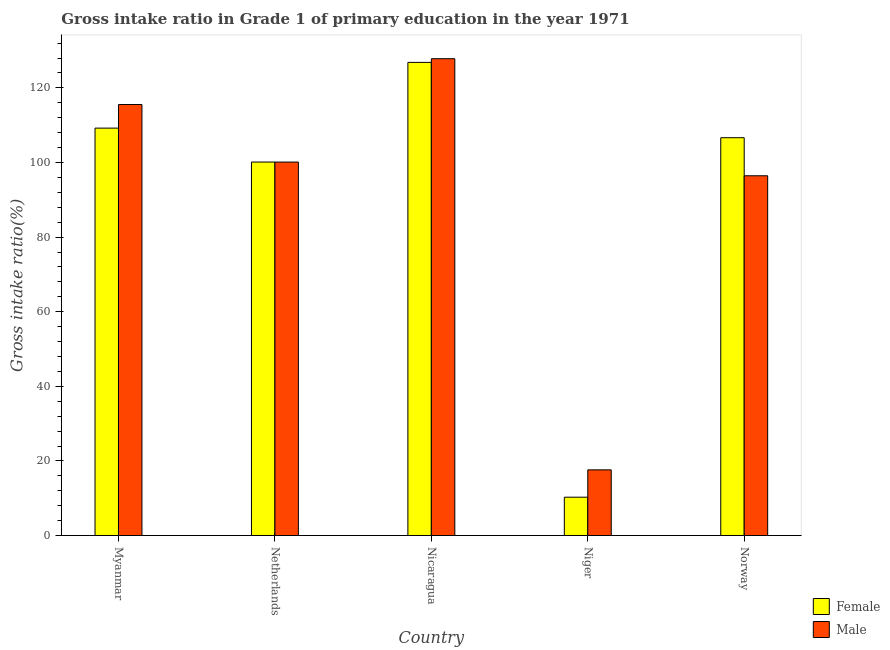How many different coloured bars are there?
Offer a very short reply. 2. Are the number of bars per tick equal to the number of legend labels?
Provide a short and direct response. Yes. How many bars are there on the 3rd tick from the left?
Make the answer very short. 2. What is the label of the 2nd group of bars from the left?
Provide a succinct answer. Netherlands. What is the gross intake ratio(female) in Niger?
Your answer should be compact. 10.28. Across all countries, what is the maximum gross intake ratio(male)?
Provide a short and direct response. 127.83. Across all countries, what is the minimum gross intake ratio(female)?
Make the answer very short. 10.28. In which country was the gross intake ratio(male) maximum?
Offer a terse response. Nicaragua. In which country was the gross intake ratio(male) minimum?
Offer a very short reply. Niger. What is the total gross intake ratio(male) in the graph?
Keep it short and to the point. 457.56. What is the difference between the gross intake ratio(female) in Myanmar and that in Nicaragua?
Provide a short and direct response. -17.62. What is the difference between the gross intake ratio(female) in Niger and the gross intake ratio(male) in Myanmar?
Your answer should be very brief. -105.26. What is the average gross intake ratio(female) per country?
Your answer should be compact. 90.63. What is the difference between the gross intake ratio(male) and gross intake ratio(female) in Niger?
Provide a short and direct response. 7.33. What is the ratio of the gross intake ratio(female) in Nicaragua to that in Norway?
Keep it short and to the point. 1.19. Is the difference between the gross intake ratio(male) in Myanmar and Nicaragua greater than the difference between the gross intake ratio(female) in Myanmar and Nicaragua?
Your answer should be compact. Yes. What is the difference between the highest and the second highest gross intake ratio(male)?
Ensure brevity in your answer.  12.28. What is the difference between the highest and the lowest gross intake ratio(female)?
Ensure brevity in your answer.  116.56. In how many countries, is the gross intake ratio(male) greater than the average gross intake ratio(male) taken over all countries?
Ensure brevity in your answer.  4. Is the sum of the gross intake ratio(male) in Myanmar and Netherlands greater than the maximum gross intake ratio(female) across all countries?
Ensure brevity in your answer.  Yes. What does the 2nd bar from the left in Myanmar represents?
Your answer should be very brief. Male. Are all the bars in the graph horizontal?
Ensure brevity in your answer.  No. How many countries are there in the graph?
Ensure brevity in your answer.  5. What is the difference between two consecutive major ticks on the Y-axis?
Provide a succinct answer. 20. Are the values on the major ticks of Y-axis written in scientific E-notation?
Your answer should be very brief. No. Does the graph contain any zero values?
Give a very brief answer. No. Does the graph contain grids?
Provide a short and direct response. No. Where does the legend appear in the graph?
Your answer should be compact. Bottom right. How are the legend labels stacked?
Offer a very short reply. Vertical. What is the title of the graph?
Your answer should be compact. Gross intake ratio in Grade 1 of primary education in the year 1971. What is the label or title of the X-axis?
Keep it short and to the point. Country. What is the label or title of the Y-axis?
Provide a short and direct response. Gross intake ratio(%). What is the Gross intake ratio(%) of Female in Myanmar?
Make the answer very short. 109.22. What is the Gross intake ratio(%) in Male in Myanmar?
Give a very brief answer. 115.55. What is the Gross intake ratio(%) of Female in Netherlands?
Your answer should be very brief. 100.13. What is the Gross intake ratio(%) of Male in Netherlands?
Offer a terse response. 100.12. What is the Gross intake ratio(%) of Female in Nicaragua?
Your response must be concise. 126.84. What is the Gross intake ratio(%) in Male in Nicaragua?
Your answer should be compact. 127.83. What is the Gross intake ratio(%) in Female in Niger?
Provide a short and direct response. 10.28. What is the Gross intake ratio(%) of Male in Niger?
Offer a terse response. 17.61. What is the Gross intake ratio(%) of Female in Norway?
Your answer should be very brief. 106.65. What is the Gross intake ratio(%) in Male in Norway?
Your answer should be very brief. 96.45. Across all countries, what is the maximum Gross intake ratio(%) in Female?
Give a very brief answer. 126.84. Across all countries, what is the maximum Gross intake ratio(%) of Male?
Give a very brief answer. 127.83. Across all countries, what is the minimum Gross intake ratio(%) of Female?
Offer a very short reply. 10.28. Across all countries, what is the minimum Gross intake ratio(%) of Male?
Give a very brief answer. 17.61. What is the total Gross intake ratio(%) of Female in the graph?
Offer a terse response. 453.13. What is the total Gross intake ratio(%) of Male in the graph?
Offer a terse response. 457.56. What is the difference between the Gross intake ratio(%) of Female in Myanmar and that in Netherlands?
Keep it short and to the point. 9.09. What is the difference between the Gross intake ratio(%) of Male in Myanmar and that in Netherlands?
Make the answer very short. 15.43. What is the difference between the Gross intake ratio(%) of Female in Myanmar and that in Nicaragua?
Keep it short and to the point. -17.62. What is the difference between the Gross intake ratio(%) of Male in Myanmar and that in Nicaragua?
Provide a short and direct response. -12.28. What is the difference between the Gross intake ratio(%) in Female in Myanmar and that in Niger?
Make the answer very short. 98.94. What is the difference between the Gross intake ratio(%) of Male in Myanmar and that in Niger?
Keep it short and to the point. 97.94. What is the difference between the Gross intake ratio(%) of Female in Myanmar and that in Norway?
Your answer should be very brief. 2.57. What is the difference between the Gross intake ratio(%) in Male in Myanmar and that in Norway?
Provide a short and direct response. 19.1. What is the difference between the Gross intake ratio(%) of Female in Netherlands and that in Nicaragua?
Your answer should be compact. -26.71. What is the difference between the Gross intake ratio(%) in Male in Netherlands and that in Nicaragua?
Keep it short and to the point. -27.7. What is the difference between the Gross intake ratio(%) of Female in Netherlands and that in Niger?
Keep it short and to the point. 89.84. What is the difference between the Gross intake ratio(%) in Male in Netherlands and that in Niger?
Your response must be concise. 82.51. What is the difference between the Gross intake ratio(%) of Female in Netherlands and that in Norway?
Offer a terse response. -6.52. What is the difference between the Gross intake ratio(%) in Male in Netherlands and that in Norway?
Provide a succinct answer. 3.67. What is the difference between the Gross intake ratio(%) of Female in Nicaragua and that in Niger?
Provide a short and direct response. 116.56. What is the difference between the Gross intake ratio(%) in Male in Nicaragua and that in Niger?
Ensure brevity in your answer.  110.22. What is the difference between the Gross intake ratio(%) in Female in Nicaragua and that in Norway?
Provide a succinct answer. 20.19. What is the difference between the Gross intake ratio(%) of Male in Nicaragua and that in Norway?
Your answer should be compact. 31.38. What is the difference between the Gross intake ratio(%) in Female in Niger and that in Norway?
Your answer should be compact. -96.37. What is the difference between the Gross intake ratio(%) of Male in Niger and that in Norway?
Your answer should be compact. -78.84. What is the difference between the Gross intake ratio(%) in Female in Myanmar and the Gross intake ratio(%) in Male in Netherlands?
Offer a terse response. 9.1. What is the difference between the Gross intake ratio(%) of Female in Myanmar and the Gross intake ratio(%) of Male in Nicaragua?
Your answer should be compact. -18.61. What is the difference between the Gross intake ratio(%) of Female in Myanmar and the Gross intake ratio(%) of Male in Niger?
Provide a succinct answer. 91.61. What is the difference between the Gross intake ratio(%) of Female in Myanmar and the Gross intake ratio(%) of Male in Norway?
Your response must be concise. 12.77. What is the difference between the Gross intake ratio(%) of Female in Netherlands and the Gross intake ratio(%) of Male in Nicaragua?
Offer a very short reply. -27.7. What is the difference between the Gross intake ratio(%) of Female in Netherlands and the Gross intake ratio(%) of Male in Niger?
Your answer should be very brief. 82.52. What is the difference between the Gross intake ratio(%) in Female in Netherlands and the Gross intake ratio(%) in Male in Norway?
Ensure brevity in your answer.  3.68. What is the difference between the Gross intake ratio(%) in Female in Nicaragua and the Gross intake ratio(%) in Male in Niger?
Ensure brevity in your answer.  109.23. What is the difference between the Gross intake ratio(%) of Female in Nicaragua and the Gross intake ratio(%) of Male in Norway?
Provide a short and direct response. 30.39. What is the difference between the Gross intake ratio(%) in Female in Niger and the Gross intake ratio(%) in Male in Norway?
Ensure brevity in your answer.  -86.16. What is the average Gross intake ratio(%) in Female per country?
Offer a terse response. 90.63. What is the average Gross intake ratio(%) of Male per country?
Your answer should be very brief. 91.51. What is the difference between the Gross intake ratio(%) in Female and Gross intake ratio(%) in Male in Myanmar?
Offer a terse response. -6.33. What is the difference between the Gross intake ratio(%) in Female and Gross intake ratio(%) in Male in Netherlands?
Ensure brevity in your answer.  0.01. What is the difference between the Gross intake ratio(%) of Female and Gross intake ratio(%) of Male in Nicaragua?
Offer a terse response. -0.98. What is the difference between the Gross intake ratio(%) of Female and Gross intake ratio(%) of Male in Niger?
Offer a very short reply. -7.33. What is the difference between the Gross intake ratio(%) in Female and Gross intake ratio(%) in Male in Norway?
Provide a short and direct response. 10.2. What is the ratio of the Gross intake ratio(%) in Female in Myanmar to that in Netherlands?
Provide a short and direct response. 1.09. What is the ratio of the Gross intake ratio(%) in Male in Myanmar to that in Netherlands?
Provide a succinct answer. 1.15. What is the ratio of the Gross intake ratio(%) in Female in Myanmar to that in Nicaragua?
Keep it short and to the point. 0.86. What is the ratio of the Gross intake ratio(%) in Male in Myanmar to that in Nicaragua?
Provide a succinct answer. 0.9. What is the ratio of the Gross intake ratio(%) in Female in Myanmar to that in Niger?
Make the answer very short. 10.62. What is the ratio of the Gross intake ratio(%) of Male in Myanmar to that in Niger?
Your answer should be very brief. 6.56. What is the ratio of the Gross intake ratio(%) in Female in Myanmar to that in Norway?
Provide a succinct answer. 1.02. What is the ratio of the Gross intake ratio(%) in Male in Myanmar to that in Norway?
Your answer should be compact. 1.2. What is the ratio of the Gross intake ratio(%) of Female in Netherlands to that in Nicaragua?
Keep it short and to the point. 0.79. What is the ratio of the Gross intake ratio(%) in Male in Netherlands to that in Nicaragua?
Your response must be concise. 0.78. What is the ratio of the Gross intake ratio(%) in Female in Netherlands to that in Niger?
Your answer should be compact. 9.74. What is the ratio of the Gross intake ratio(%) in Male in Netherlands to that in Niger?
Keep it short and to the point. 5.69. What is the ratio of the Gross intake ratio(%) of Female in Netherlands to that in Norway?
Offer a very short reply. 0.94. What is the ratio of the Gross intake ratio(%) of Male in Netherlands to that in Norway?
Your answer should be very brief. 1.04. What is the ratio of the Gross intake ratio(%) of Female in Nicaragua to that in Niger?
Ensure brevity in your answer.  12.33. What is the ratio of the Gross intake ratio(%) in Male in Nicaragua to that in Niger?
Offer a terse response. 7.26. What is the ratio of the Gross intake ratio(%) in Female in Nicaragua to that in Norway?
Keep it short and to the point. 1.19. What is the ratio of the Gross intake ratio(%) in Male in Nicaragua to that in Norway?
Your response must be concise. 1.33. What is the ratio of the Gross intake ratio(%) of Female in Niger to that in Norway?
Your answer should be very brief. 0.1. What is the ratio of the Gross intake ratio(%) of Male in Niger to that in Norway?
Ensure brevity in your answer.  0.18. What is the difference between the highest and the second highest Gross intake ratio(%) in Female?
Offer a terse response. 17.62. What is the difference between the highest and the second highest Gross intake ratio(%) in Male?
Keep it short and to the point. 12.28. What is the difference between the highest and the lowest Gross intake ratio(%) in Female?
Provide a succinct answer. 116.56. What is the difference between the highest and the lowest Gross intake ratio(%) in Male?
Your answer should be very brief. 110.22. 